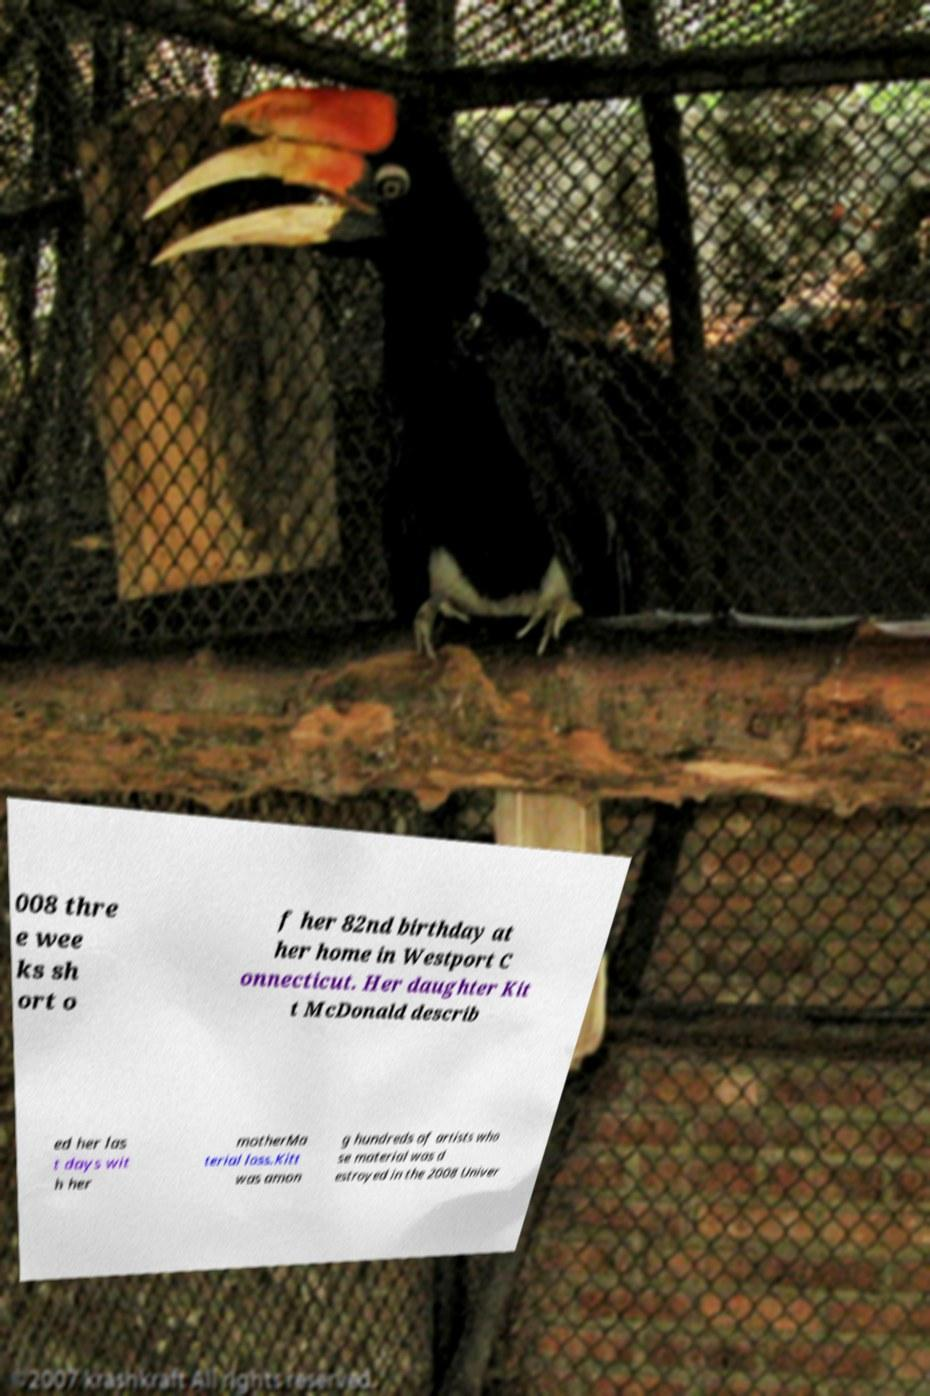Please read and relay the text visible in this image. What does it say? 008 thre e wee ks sh ort o f her 82nd birthday at her home in Westport C onnecticut. Her daughter Kit t McDonald describ ed her las t days wit h her motherMa terial loss.Kitt was amon g hundreds of artists who se material was d estroyed in the 2008 Univer 